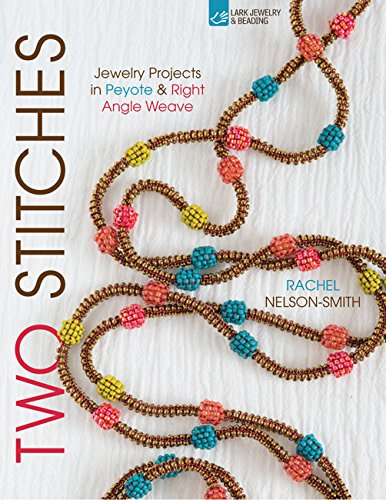What is the genre of this book? This book falls under the genre of 'Crafts, Hobbies & Home', specifically catering to enthusiasts of jewelry making and bead weaving crafts. 